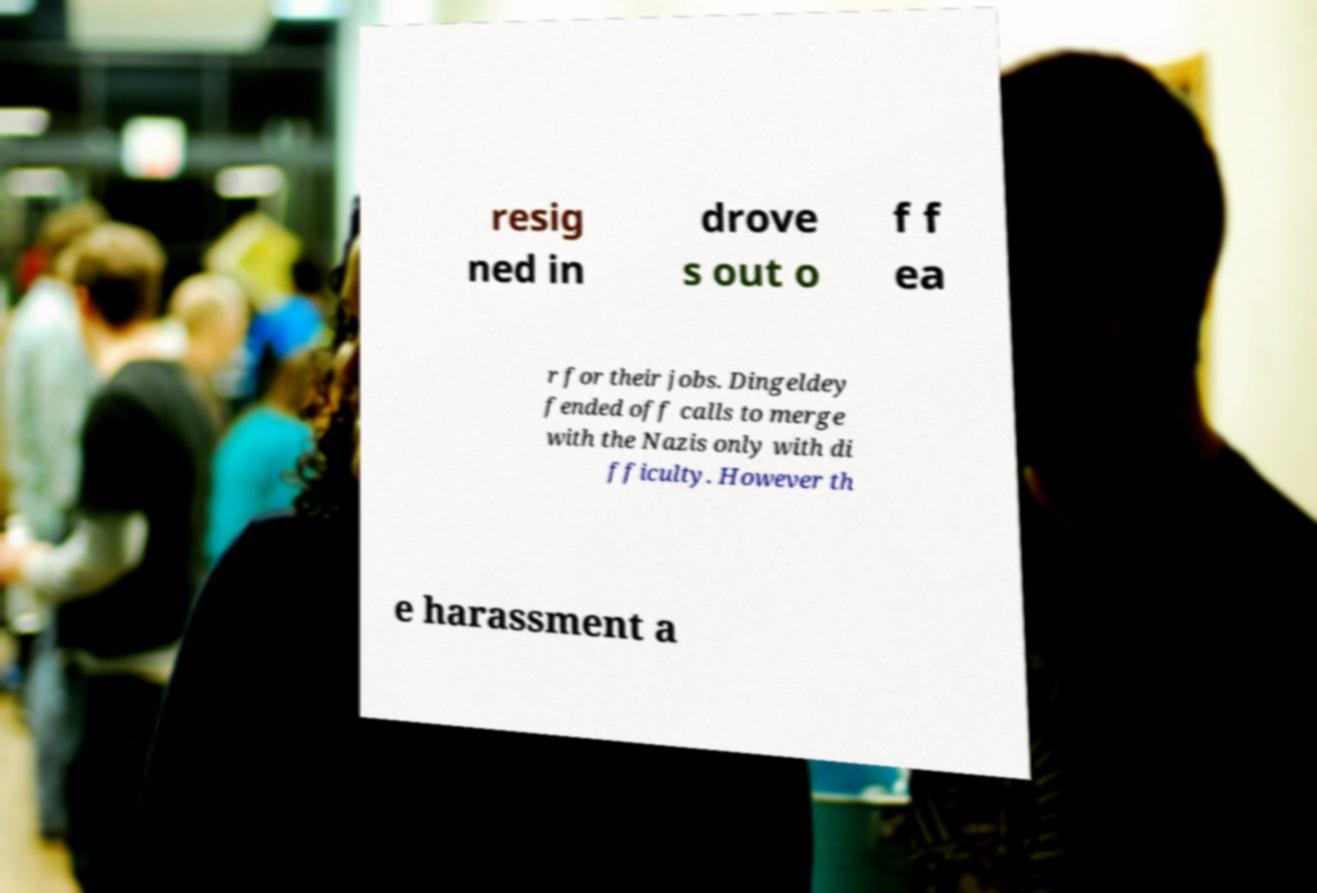Could you extract and type out the text from this image? resig ned in drove s out o f f ea r for their jobs. Dingeldey fended off calls to merge with the Nazis only with di fficulty. However th e harassment a 